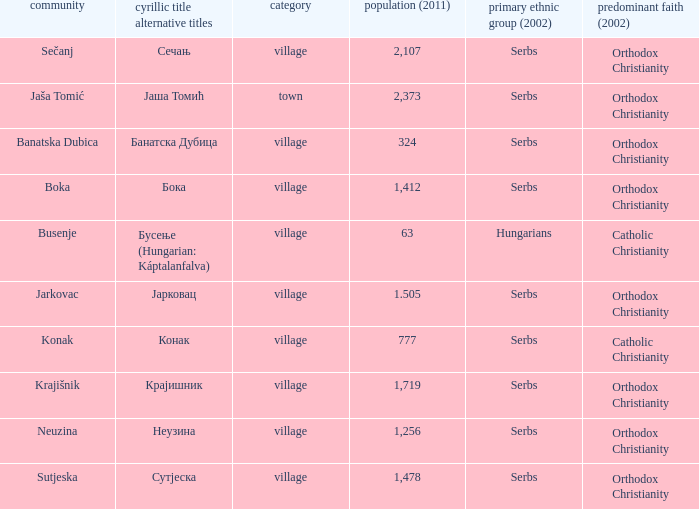What kind of type is  бока? Village. 